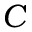<formula> <loc_0><loc_0><loc_500><loc_500>C</formula> 